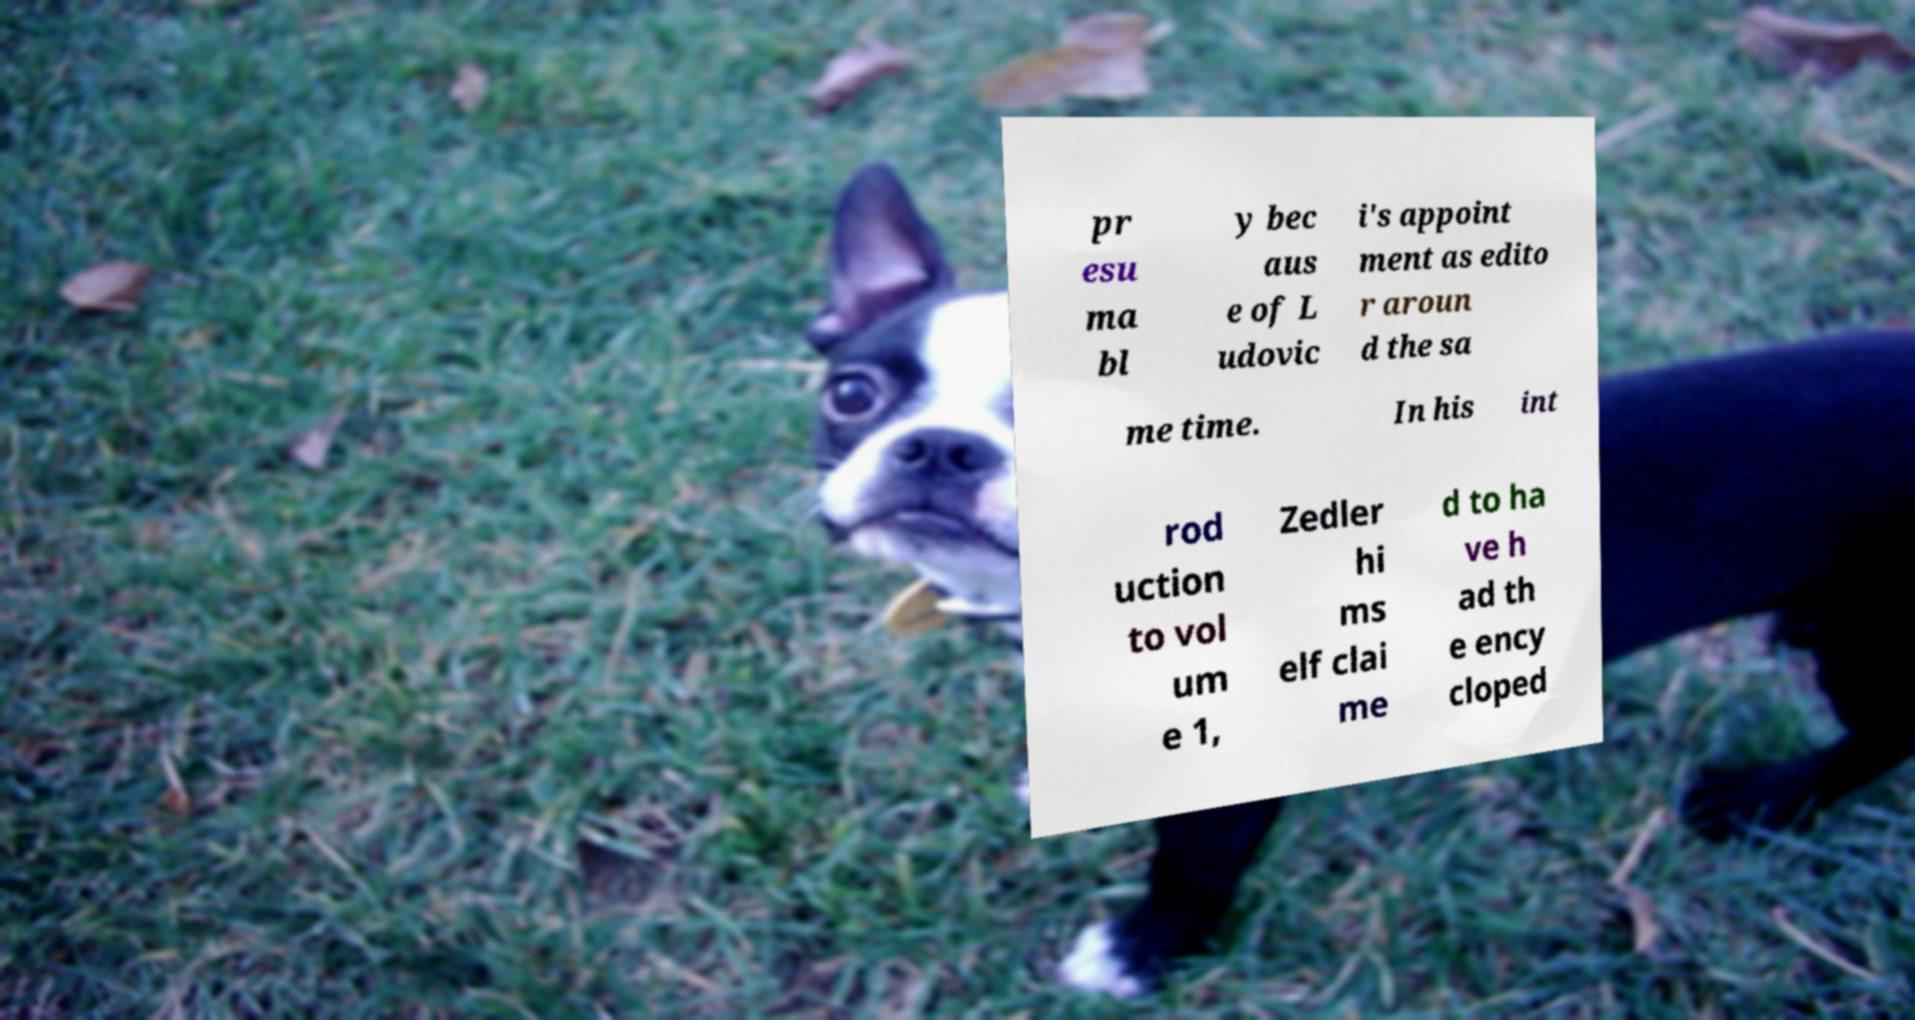What messages or text are displayed in this image? I need them in a readable, typed format. pr esu ma bl y bec aus e of L udovic i's appoint ment as edito r aroun d the sa me time. In his int rod uction to vol um e 1, Zedler hi ms elf clai me d to ha ve h ad th e ency cloped 